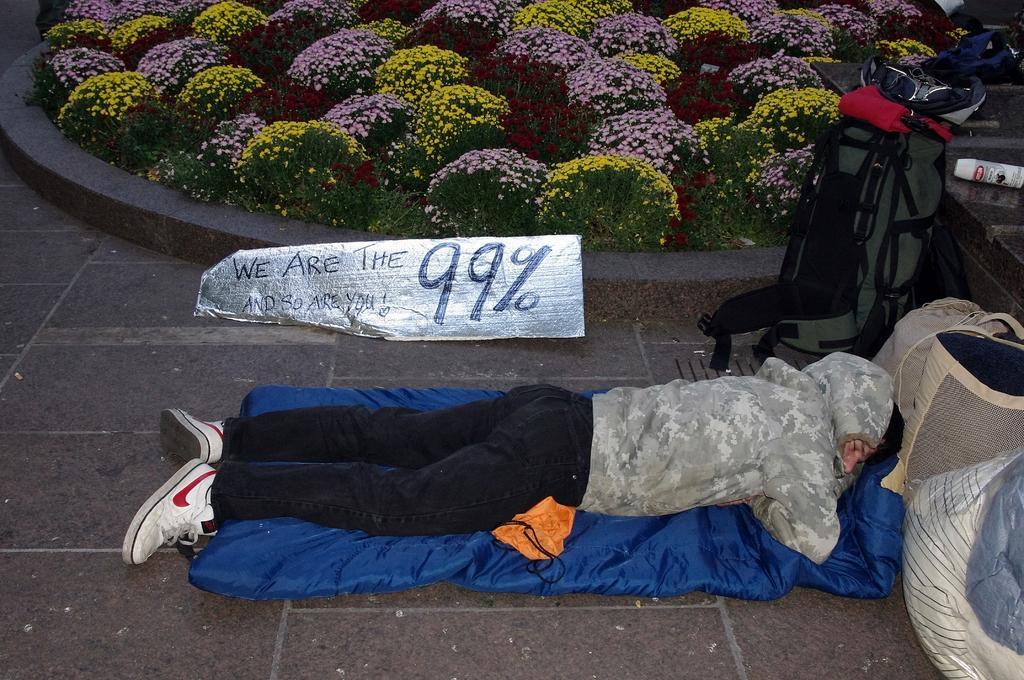In one or two sentences, can you explain what this image depicts? In this image there is a person sleeping on bed with luggage near his head, beside that there are so many flower plants and aluminium paper with some note. 